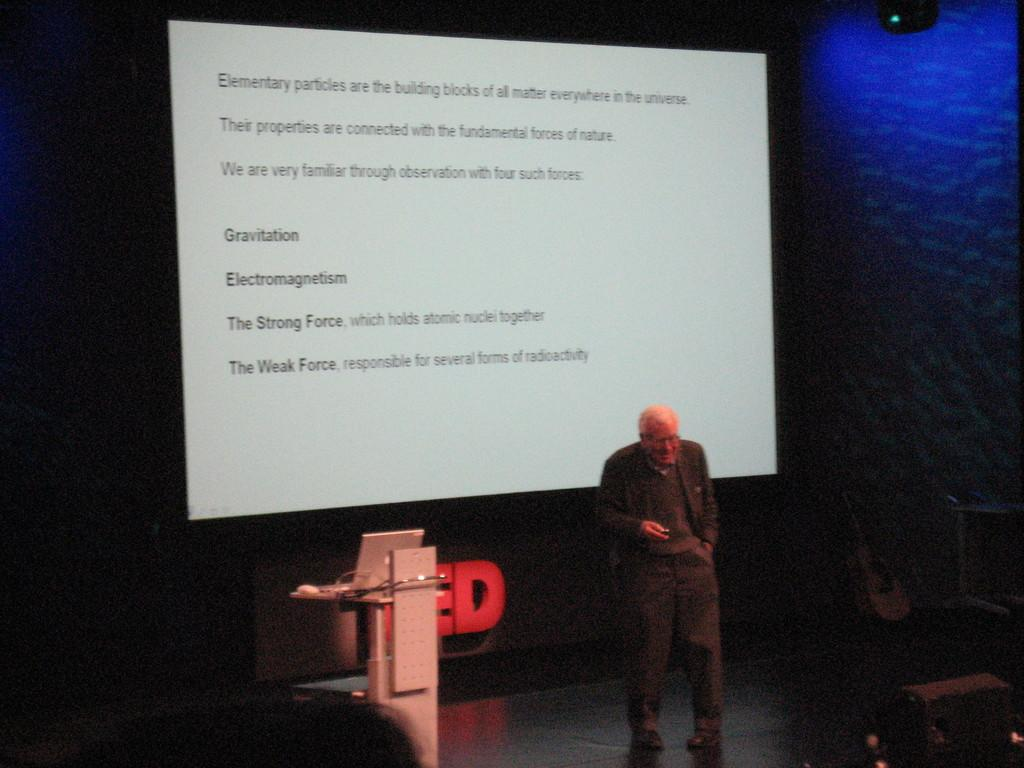What is the main subject in the image? There is a man standing in the image. Where is the man standing? The man is standing on the floor. What can be seen on the screen in the image? The facts do not specify what is on the screen, so we cannot answer that question. What is the purpose of the podium in the image? The podium might be used for presentations or speeches. What device is present in the image? There is a laptop in the image. Can you describe the objects in the image? The facts do not specify the objects, so we cannot answer that question. What is the color of the background in the image? The background of the image is dark. What type of attraction can be seen in the image? There is no attraction present in the image; it features a man standing with a screen, podium, and laptop. How does the man express anger in the image? The facts do not mention any emotions or expressions, so we cannot answer that question. 